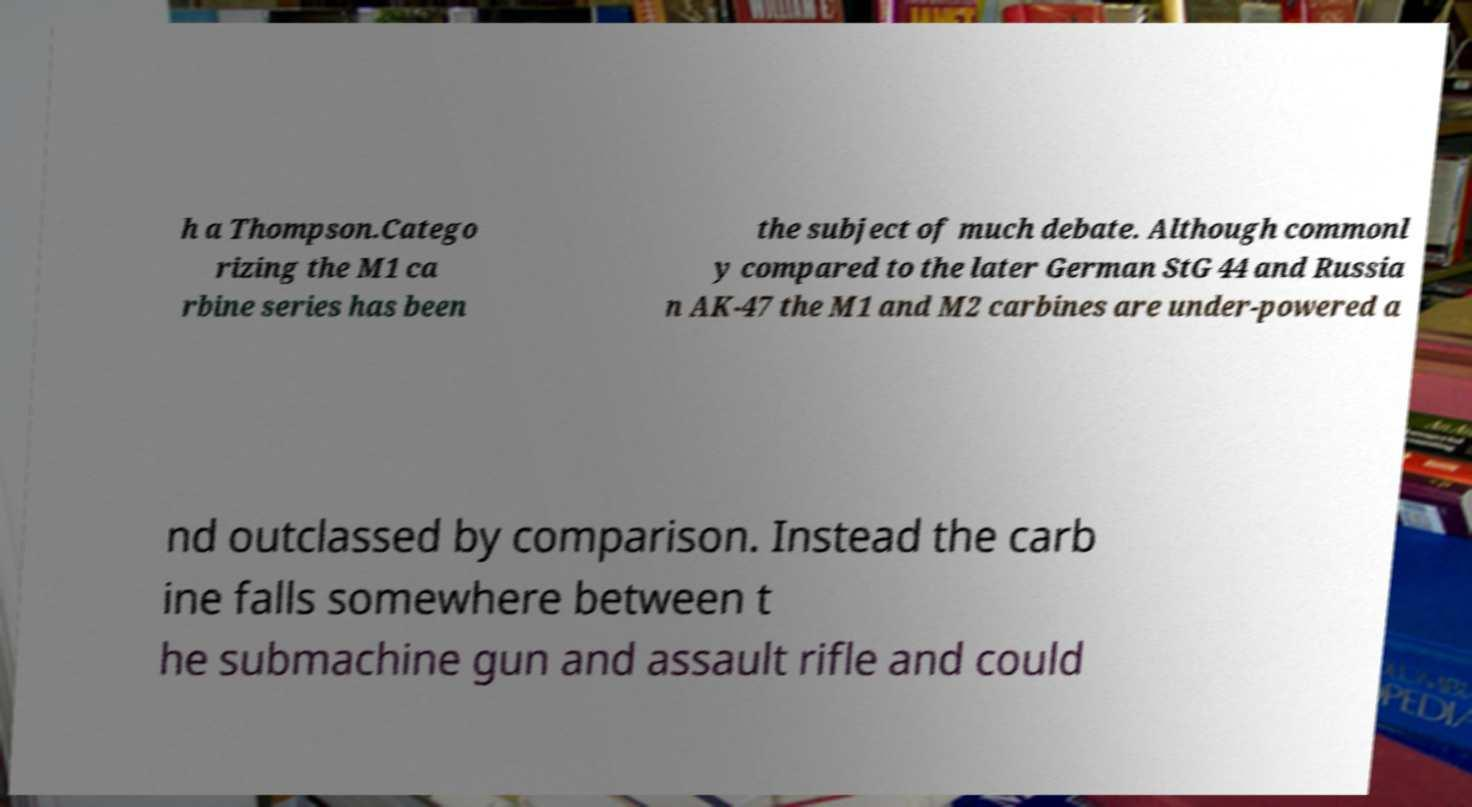Please read and relay the text visible in this image. What does it say? h a Thompson.Catego rizing the M1 ca rbine series has been the subject of much debate. Although commonl y compared to the later German StG 44 and Russia n AK-47 the M1 and M2 carbines are under-powered a nd outclassed by comparison. Instead the carb ine falls somewhere between t he submachine gun and assault rifle and could 